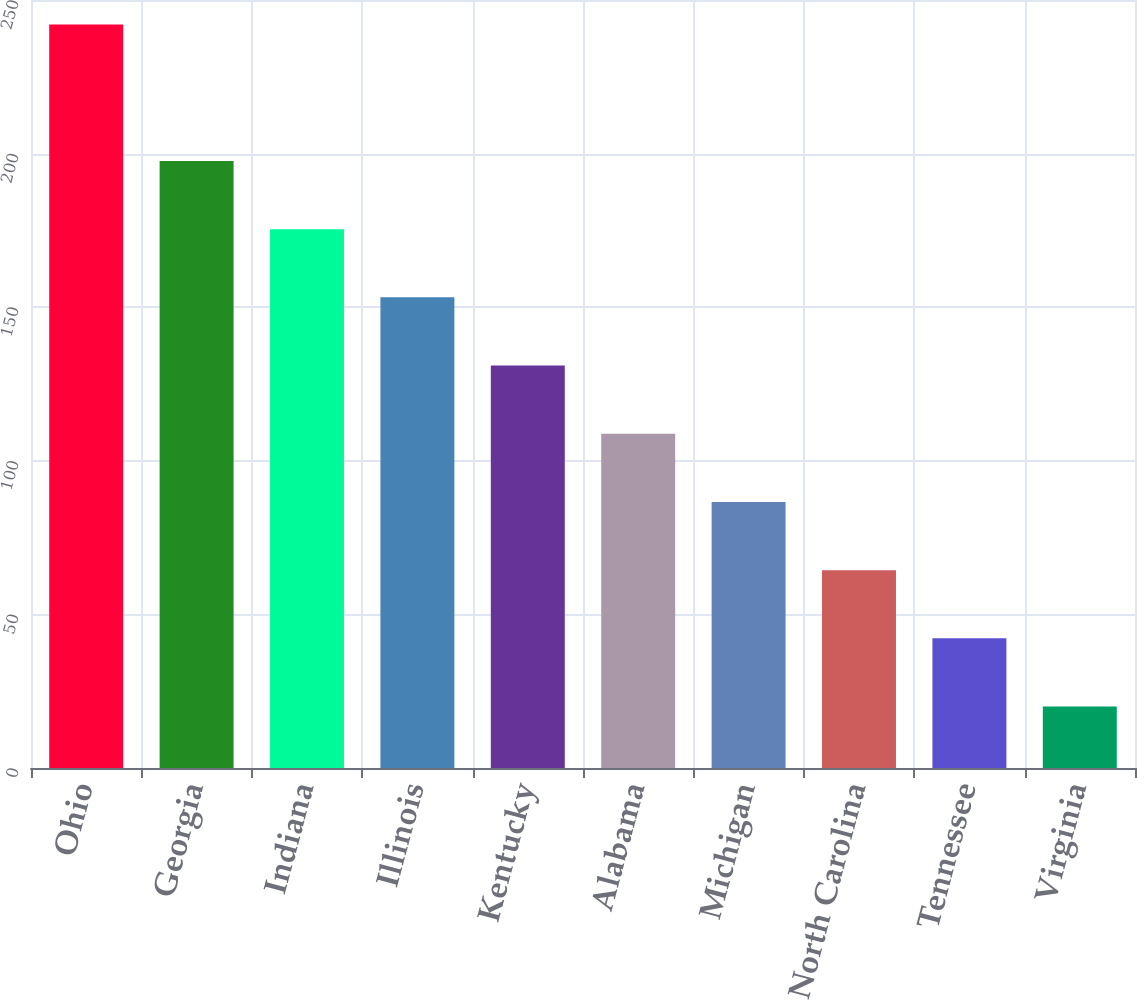Convert chart to OTSL. <chart><loc_0><loc_0><loc_500><loc_500><bar_chart><fcel>Ohio<fcel>Georgia<fcel>Indiana<fcel>Illinois<fcel>Kentucky<fcel>Alabama<fcel>Michigan<fcel>North Carolina<fcel>Tennessee<fcel>Virginia<nl><fcel>242<fcel>197.6<fcel>175.4<fcel>153.2<fcel>131<fcel>108.8<fcel>86.6<fcel>64.4<fcel>42.2<fcel>20<nl></chart> 